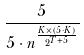<formula> <loc_0><loc_0><loc_500><loc_500>\frac { 5 } { 5 \cdot n ^ { \frac { K \times ( 5 \cdot K ) } { 2 ^ { T + 5 } } } }</formula> 